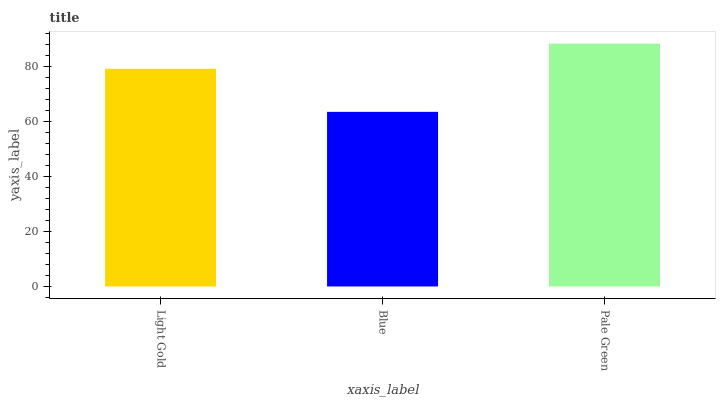Is Blue the minimum?
Answer yes or no. Yes. Is Pale Green the maximum?
Answer yes or no. Yes. Is Pale Green the minimum?
Answer yes or no. No. Is Blue the maximum?
Answer yes or no. No. Is Pale Green greater than Blue?
Answer yes or no. Yes. Is Blue less than Pale Green?
Answer yes or no. Yes. Is Blue greater than Pale Green?
Answer yes or no. No. Is Pale Green less than Blue?
Answer yes or no. No. Is Light Gold the high median?
Answer yes or no. Yes. Is Light Gold the low median?
Answer yes or no. Yes. Is Pale Green the high median?
Answer yes or no. No. Is Pale Green the low median?
Answer yes or no. No. 